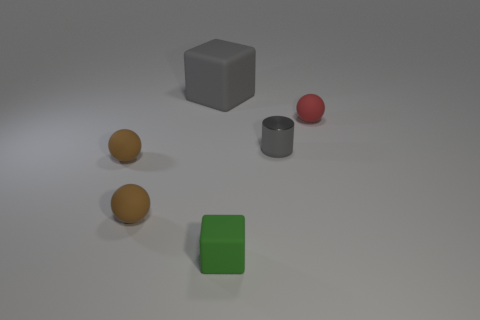Are there more gray cylinders that are on the left side of the small red rubber ball than gray cylinders that are in front of the metallic object?
Ensure brevity in your answer.  Yes. How many objects are either cubes or small rubber things?
Provide a short and direct response. 5. How many other things are there of the same color as the shiny cylinder?
Offer a very short reply. 1. The red rubber object that is the same size as the metallic cylinder is what shape?
Your answer should be very brief. Sphere. The matte object that is behind the red object is what color?
Provide a short and direct response. Gray. How many objects are tiny spheres on the right side of the gray matte cube or spheres that are to the right of the cylinder?
Your answer should be compact. 1. Do the gray metal cylinder and the gray rubber thing have the same size?
Offer a terse response. No. What number of balls are either large gray rubber objects or small red objects?
Ensure brevity in your answer.  1. What number of small matte objects are to the left of the cylinder and behind the green cube?
Your answer should be very brief. 2. There is a gray cylinder; is its size the same as the gray thing that is behind the gray metallic cylinder?
Provide a succinct answer. No. 